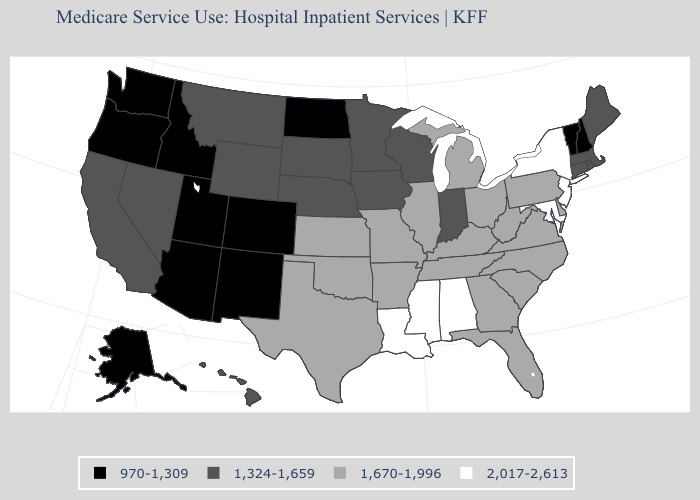Name the states that have a value in the range 970-1,309?
Write a very short answer. Alaska, Arizona, Colorado, Idaho, New Hampshire, New Mexico, North Dakota, Oregon, Utah, Vermont, Washington. Name the states that have a value in the range 2,017-2,613?
Short answer required. Alabama, Louisiana, Maryland, Mississippi, New Jersey, New York. What is the value of Iowa?
Keep it brief. 1,324-1,659. Does the first symbol in the legend represent the smallest category?
Short answer required. Yes. What is the value of Maryland?
Answer briefly. 2,017-2,613. What is the lowest value in states that border Mississippi?
Be succinct. 1,670-1,996. Does North Dakota have the lowest value in the MidWest?
Concise answer only. Yes. Does the map have missing data?
Answer briefly. No. What is the lowest value in states that border Virginia?
Answer briefly. 1,670-1,996. What is the highest value in the West ?
Be succinct. 1,324-1,659. Name the states that have a value in the range 1,324-1,659?
Answer briefly. California, Connecticut, Hawaii, Indiana, Iowa, Maine, Massachusetts, Minnesota, Montana, Nebraska, Nevada, Rhode Island, South Dakota, Wisconsin, Wyoming. Does Rhode Island have the same value as Iowa?
Concise answer only. Yes. What is the value of Vermont?
Keep it brief. 970-1,309. Does New Mexico have the same value as Nebraska?
Quick response, please. No. 